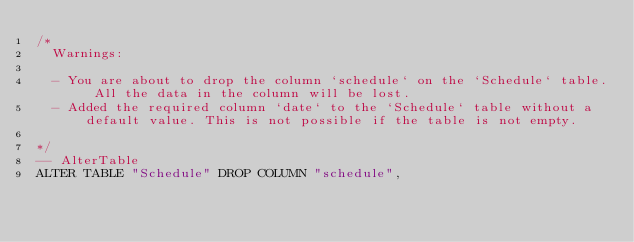<code> <loc_0><loc_0><loc_500><loc_500><_SQL_>/*
  Warnings:

  - You are about to drop the column `schedule` on the `Schedule` table. All the data in the column will be lost.
  - Added the required column `date` to the `Schedule` table without a default value. This is not possible if the table is not empty.

*/
-- AlterTable
ALTER TABLE "Schedule" DROP COLUMN "schedule",</code> 